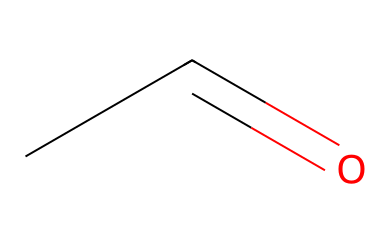What is the name of this chemical? The SMILES representation CC=O corresponds to acetaldehyde, which is the common name for this molecule.
Answer: acetaldehyde How many carbon atoms are in acetaldehyde? The SMILES CC=O indicates that there is one carbon (C) atom in the chain represented before the carbonyl group (C=O).
Answer: one What functional group is present in this molecule? The structure contains a carbonyl group (C=O) at the end of the carbon chain, which is characteristic of aldehydes.
Answer: carbonyl What is the total number of hydrogen atoms in acetaldehyde? In the structure of acetaldehyde, there is one carbon, one oxygen, and two hydrogen (H) atoms attached to the carbon chain (since it's an aldehyde, it has an H attached to the carbonyl carbon).
Answer: four Which type of chemical compound does acetaldehyde belong to? As indicated by the presence of the carbonyl group attached to a carbon atom with an H, acetaldehyde is classified as an aldehyde.
Answer: aldehyde Why does acetaldehyde have a strong odor? The molecule has a short carbon chain and a carbonyl group, which are often associated with volatile compounds, allowing it to easily evaporate and contribute to its distinct strong odor.
Answer: strong odor What is the impact of acetaldehyde in traditional fermented beverages? Acetaldehyde is a byproduct of fermentation, and its presence contributes to the flavor profile of traditional fermented beverages, influencing their taste and aroma.
Answer: flavor profile 